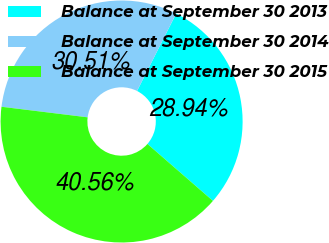<chart> <loc_0><loc_0><loc_500><loc_500><pie_chart><fcel>Balance at September 30 2013<fcel>Balance at September 30 2014<fcel>Balance at September 30 2015<nl><fcel>28.94%<fcel>30.51%<fcel>40.56%<nl></chart> 